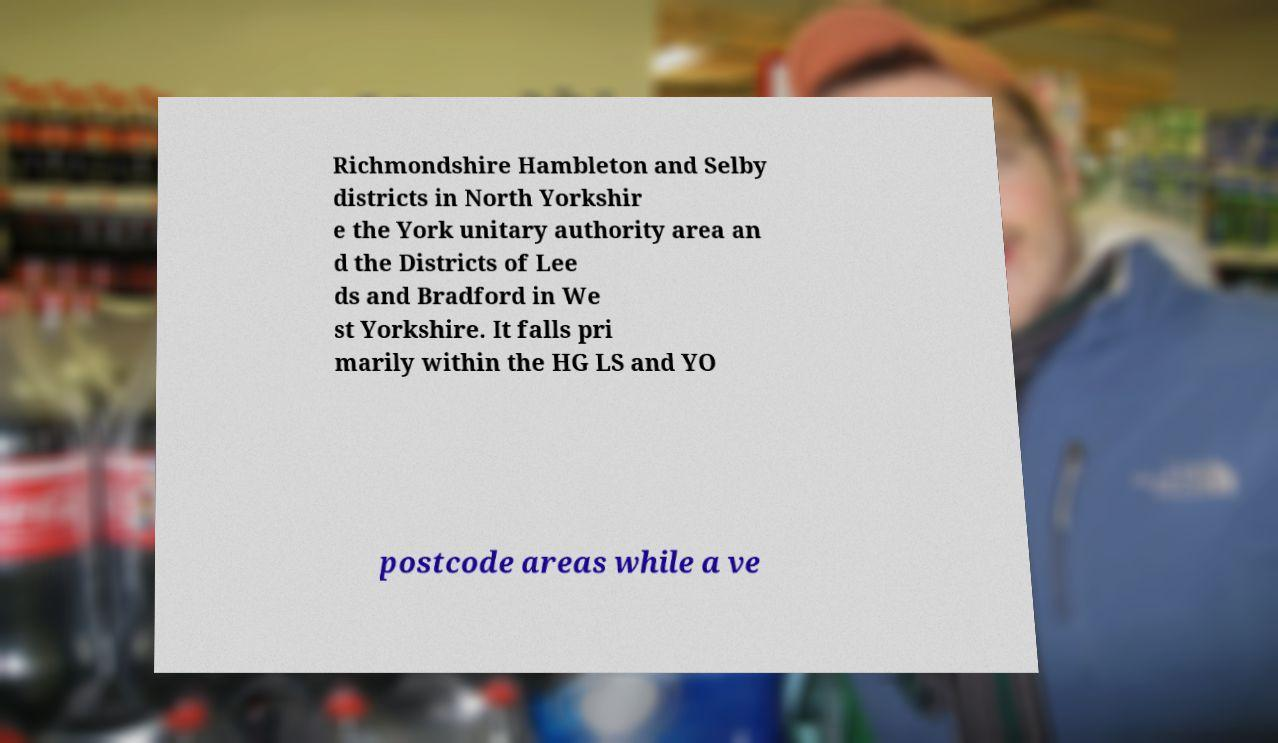There's text embedded in this image that I need extracted. Can you transcribe it verbatim? Richmondshire Hambleton and Selby districts in North Yorkshir e the York unitary authority area an d the Districts of Lee ds and Bradford in We st Yorkshire. It falls pri marily within the HG LS and YO postcode areas while a ve 